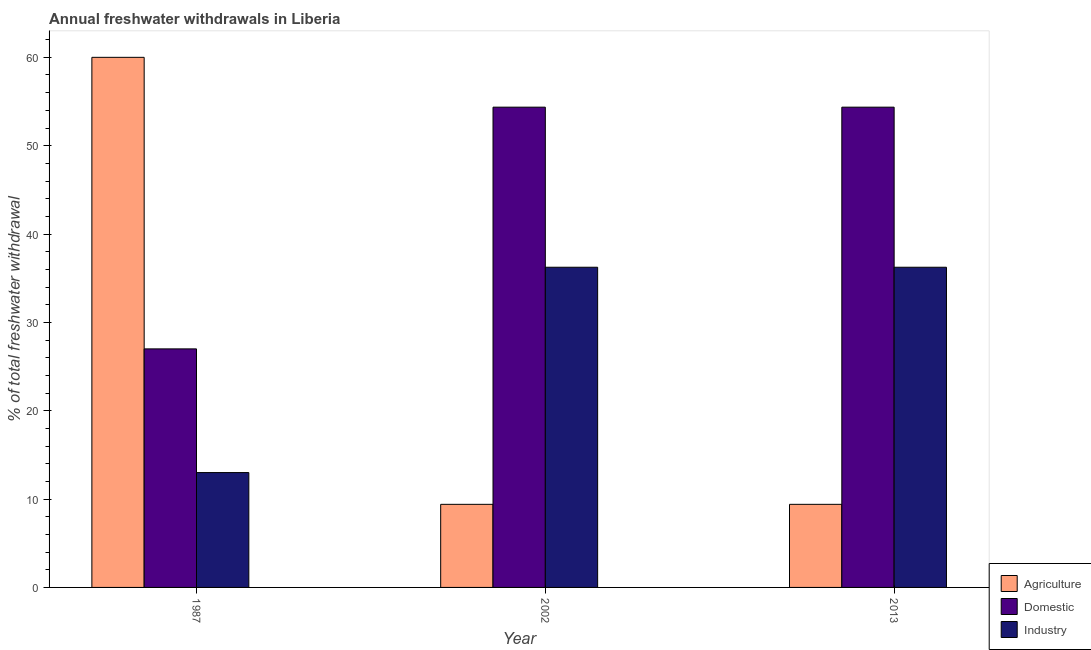How many different coloured bars are there?
Your answer should be very brief. 3. How many groups of bars are there?
Your answer should be very brief. 3. Are the number of bars per tick equal to the number of legend labels?
Your response must be concise. Yes. Are the number of bars on each tick of the X-axis equal?
Make the answer very short. Yes. How many bars are there on the 1st tick from the right?
Keep it short and to the point. 3. In how many cases, is the number of bars for a given year not equal to the number of legend labels?
Keep it short and to the point. 0. What is the percentage of freshwater withdrawal for industry in 2013?
Provide a short and direct response. 36.24. Across all years, what is the minimum percentage of freshwater withdrawal for agriculture?
Keep it short and to the point. 9.4. In which year was the percentage of freshwater withdrawal for industry maximum?
Ensure brevity in your answer.  2002. What is the total percentage of freshwater withdrawal for agriculture in the graph?
Ensure brevity in your answer.  78.81. What is the difference between the percentage of freshwater withdrawal for domestic purposes in 2002 and that in 2013?
Give a very brief answer. 0. What is the difference between the percentage of freshwater withdrawal for domestic purposes in 1987 and the percentage of freshwater withdrawal for industry in 2002?
Offer a very short reply. -27.36. What is the average percentage of freshwater withdrawal for domestic purposes per year?
Make the answer very short. 45.24. What is the ratio of the percentage of freshwater withdrawal for domestic purposes in 1987 to that in 2013?
Your answer should be compact. 0.5. Is the difference between the percentage of freshwater withdrawal for agriculture in 1987 and 2002 greater than the difference between the percentage of freshwater withdrawal for industry in 1987 and 2002?
Offer a very short reply. No. What is the difference between the highest and the lowest percentage of freshwater withdrawal for domestic purposes?
Ensure brevity in your answer.  27.36. In how many years, is the percentage of freshwater withdrawal for agriculture greater than the average percentage of freshwater withdrawal for agriculture taken over all years?
Offer a very short reply. 1. What does the 1st bar from the left in 1987 represents?
Provide a succinct answer. Agriculture. What does the 1st bar from the right in 2002 represents?
Make the answer very short. Industry. Is it the case that in every year, the sum of the percentage of freshwater withdrawal for agriculture and percentage of freshwater withdrawal for domestic purposes is greater than the percentage of freshwater withdrawal for industry?
Provide a succinct answer. Yes. How many years are there in the graph?
Ensure brevity in your answer.  3. Does the graph contain grids?
Your answer should be compact. No. How many legend labels are there?
Your answer should be very brief. 3. How are the legend labels stacked?
Provide a short and direct response. Vertical. What is the title of the graph?
Offer a terse response. Annual freshwater withdrawals in Liberia. What is the label or title of the X-axis?
Your answer should be very brief. Year. What is the label or title of the Y-axis?
Offer a terse response. % of total freshwater withdrawal. What is the % of total freshwater withdrawal of Agriculture in 1987?
Provide a short and direct response. 60. What is the % of total freshwater withdrawal of Agriculture in 2002?
Provide a succinct answer. 9.4. What is the % of total freshwater withdrawal of Domestic in 2002?
Provide a short and direct response. 54.36. What is the % of total freshwater withdrawal in Industry in 2002?
Your response must be concise. 36.24. What is the % of total freshwater withdrawal in Agriculture in 2013?
Make the answer very short. 9.4. What is the % of total freshwater withdrawal in Domestic in 2013?
Your response must be concise. 54.36. What is the % of total freshwater withdrawal in Industry in 2013?
Make the answer very short. 36.24. Across all years, what is the maximum % of total freshwater withdrawal in Domestic?
Your response must be concise. 54.36. Across all years, what is the maximum % of total freshwater withdrawal in Industry?
Offer a very short reply. 36.24. Across all years, what is the minimum % of total freshwater withdrawal in Agriculture?
Provide a succinct answer. 9.4. What is the total % of total freshwater withdrawal of Agriculture in the graph?
Your answer should be very brief. 78.81. What is the total % of total freshwater withdrawal in Domestic in the graph?
Give a very brief answer. 135.72. What is the total % of total freshwater withdrawal of Industry in the graph?
Give a very brief answer. 85.48. What is the difference between the % of total freshwater withdrawal of Agriculture in 1987 and that in 2002?
Keep it short and to the point. 50.6. What is the difference between the % of total freshwater withdrawal in Domestic in 1987 and that in 2002?
Your answer should be compact. -27.36. What is the difference between the % of total freshwater withdrawal of Industry in 1987 and that in 2002?
Give a very brief answer. -23.24. What is the difference between the % of total freshwater withdrawal of Agriculture in 1987 and that in 2013?
Offer a terse response. 50.6. What is the difference between the % of total freshwater withdrawal in Domestic in 1987 and that in 2013?
Offer a very short reply. -27.36. What is the difference between the % of total freshwater withdrawal in Industry in 1987 and that in 2013?
Give a very brief answer. -23.24. What is the difference between the % of total freshwater withdrawal in Industry in 2002 and that in 2013?
Keep it short and to the point. 0. What is the difference between the % of total freshwater withdrawal of Agriculture in 1987 and the % of total freshwater withdrawal of Domestic in 2002?
Provide a succinct answer. 5.64. What is the difference between the % of total freshwater withdrawal of Agriculture in 1987 and the % of total freshwater withdrawal of Industry in 2002?
Your response must be concise. 23.76. What is the difference between the % of total freshwater withdrawal of Domestic in 1987 and the % of total freshwater withdrawal of Industry in 2002?
Ensure brevity in your answer.  -9.24. What is the difference between the % of total freshwater withdrawal in Agriculture in 1987 and the % of total freshwater withdrawal in Domestic in 2013?
Provide a succinct answer. 5.64. What is the difference between the % of total freshwater withdrawal in Agriculture in 1987 and the % of total freshwater withdrawal in Industry in 2013?
Your answer should be compact. 23.76. What is the difference between the % of total freshwater withdrawal in Domestic in 1987 and the % of total freshwater withdrawal in Industry in 2013?
Give a very brief answer. -9.24. What is the difference between the % of total freshwater withdrawal in Agriculture in 2002 and the % of total freshwater withdrawal in Domestic in 2013?
Make the answer very short. -44.96. What is the difference between the % of total freshwater withdrawal in Agriculture in 2002 and the % of total freshwater withdrawal in Industry in 2013?
Offer a very short reply. -26.84. What is the difference between the % of total freshwater withdrawal in Domestic in 2002 and the % of total freshwater withdrawal in Industry in 2013?
Keep it short and to the point. 18.12. What is the average % of total freshwater withdrawal of Agriculture per year?
Offer a very short reply. 26.27. What is the average % of total freshwater withdrawal in Domestic per year?
Your answer should be compact. 45.24. What is the average % of total freshwater withdrawal in Industry per year?
Offer a terse response. 28.49. In the year 2002, what is the difference between the % of total freshwater withdrawal of Agriculture and % of total freshwater withdrawal of Domestic?
Offer a very short reply. -44.96. In the year 2002, what is the difference between the % of total freshwater withdrawal in Agriculture and % of total freshwater withdrawal in Industry?
Keep it short and to the point. -26.84. In the year 2002, what is the difference between the % of total freshwater withdrawal of Domestic and % of total freshwater withdrawal of Industry?
Make the answer very short. 18.12. In the year 2013, what is the difference between the % of total freshwater withdrawal of Agriculture and % of total freshwater withdrawal of Domestic?
Offer a terse response. -44.96. In the year 2013, what is the difference between the % of total freshwater withdrawal in Agriculture and % of total freshwater withdrawal in Industry?
Provide a short and direct response. -26.84. In the year 2013, what is the difference between the % of total freshwater withdrawal in Domestic and % of total freshwater withdrawal in Industry?
Offer a terse response. 18.12. What is the ratio of the % of total freshwater withdrawal in Agriculture in 1987 to that in 2002?
Your answer should be compact. 6.38. What is the ratio of the % of total freshwater withdrawal in Domestic in 1987 to that in 2002?
Keep it short and to the point. 0.5. What is the ratio of the % of total freshwater withdrawal in Industry in 1987 to that in 2002?
Keep it short and to the point. 0.36. What is the ratio of the % of total freshwater withdrawal in Agriculture in 1987 to that in 2013?
Your answer should be compact. 6.38. What is the ratio of the % of total freshwater withdrawal of Domestic in 1987 to that in 2013?
Make the answer very short. 0.5. What is the ratio of the % of total freshwater withdrawal in Industry in 1987 to that in 2013?
Offer a terse response. 0.36. What is the ratio of the % of total freshwater withdrawal in Agriculture in 2002 to that in 2013?
Keep it short and to the point. 1. What is the ratio of the % of total freshwater withdrawal of Domestic in 2002 to that in 2013?
Keep it short and to the point. 1. What is the ratio of the % of total freshwater withdrawal in Industry in 2002 to that in 2013?
Your response must be concise. 1. What is the difference between the highest and the second highest % of total freshwater withdrawal in Agriculture?
Offer a terse response. 50.6. What is the difference between the highest and the lowest % of total freshwater withdrawal of Agriculture?
Your answer should be compact. 50.6. What is the difference between the highest and the lowest % of total freshwater withdrawal of Domestic?
Offer a terse response. 27.36. What is the difference between the highest and the lowest % of total freshwater withdrawal of Industry?
Your response must be concise. 23.24. 